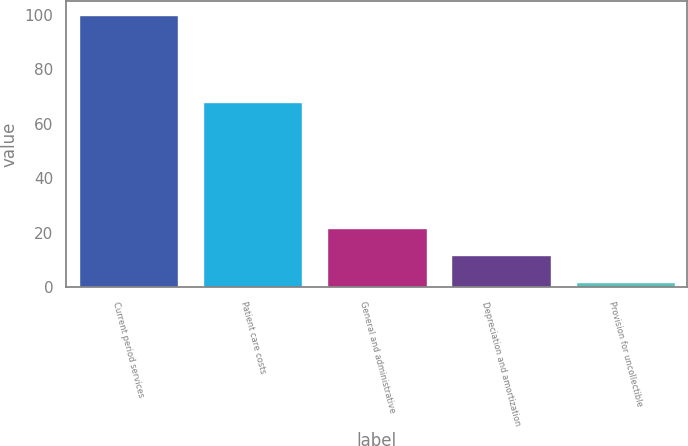Convert chart to OTSL. <chart><loc_0><loc_0><loc_500><loc_500><bar_chart><fcel>Current period services<fcel>Patient care costs<fcel>General and administrative<fcel>Depreciation and amortization<fcel>Provision for uncollectible<nl><fcel>100<fcel>68<fcel>21.6<fcel>11.8<fcel>2<nl></chart> 